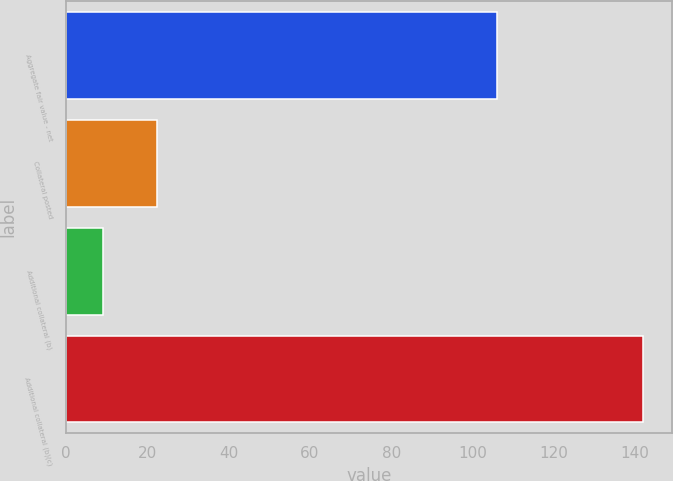Convert chart to OTSL. <chart><loc_0><loc_0><loc_500><loc_500><bar_chart><fcel>Aggregate fair value - net<fcel>Collateral posted<fcel>Additional collateral (b)<fcel>Additional collateral (b)(c)<nl><fcel>106<fcel>22.3<fcel>9<fcel>142<nl></chart> 